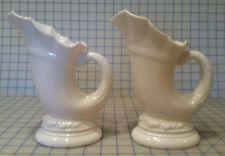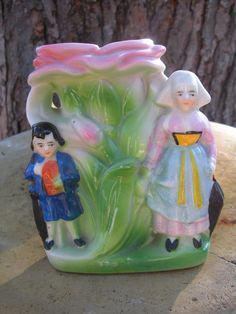The first image is the image on the left, the second image is the image on the right. For the images displayed, is the sentence "Each image contains at least two vases shaped like ocean waves, and the left image shows the waves facing each other, while the right image shows them aimed leftward." factually correct? Answer yes or no. No. The first image is the image on the left, the second image is the image on the right. Considering the images on both sides, is "Each image contains a pair of matching objects." valid? Answer yes or no. No. 